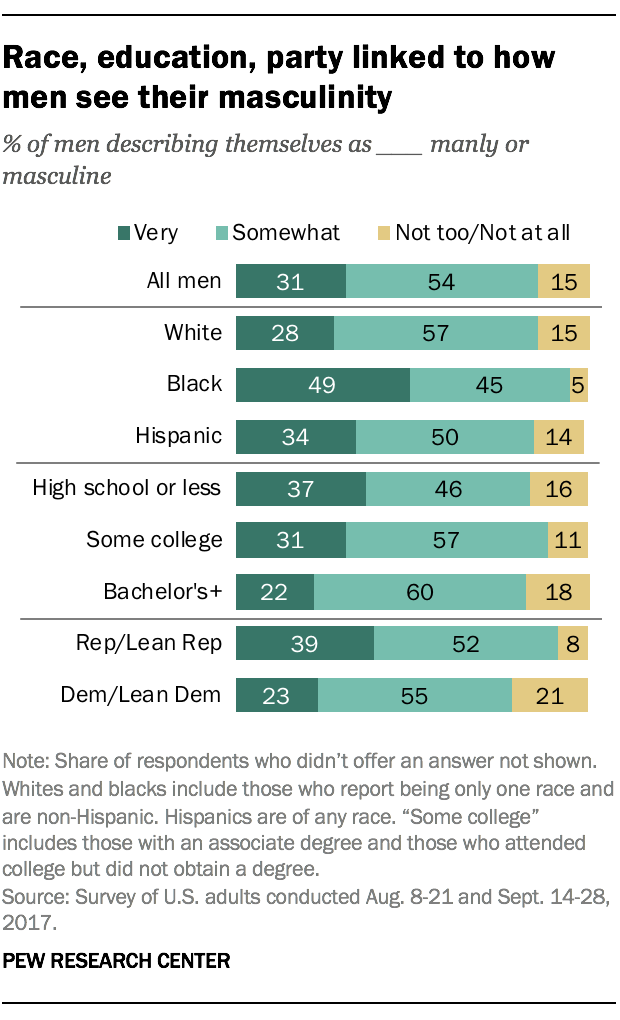Point out several critical features in this image. The largest value and the smallest value in the graph bar add up to 65. The color of the right-side segment of the graph bar is yellow. 